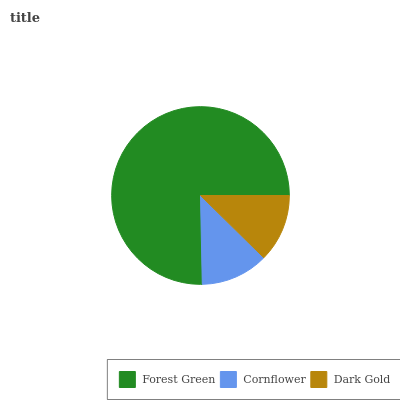Is Cornflower the minimum?
Answer yes or no. Yes. Is Forest Green the maximum?
Answer yes or no. Yes. Is Dark Gold the minimum?
Answer yes or no. No. Is Dark Gold the maximum?
Answer yes or no. No. Is Dark Gold greater than Cornflower?
Answer yes or no. Yes. Is Cornflower less than Dark Gold?
Answer yes or no. Yes. Is Cornflower greater than Dark Gold?
Answer yes or no. No. Is Dark Gold less than Cornflower?
Answer yes or no. No. Is Dark Gold the high median?
Answer yes or no. Yes. Is Dark Gold the low median?
Answer yes or no. Yes. Is Forest Green the high median?
Answer yes or no. No. Is Cornflower the low median?
Answer yes or no. No. 